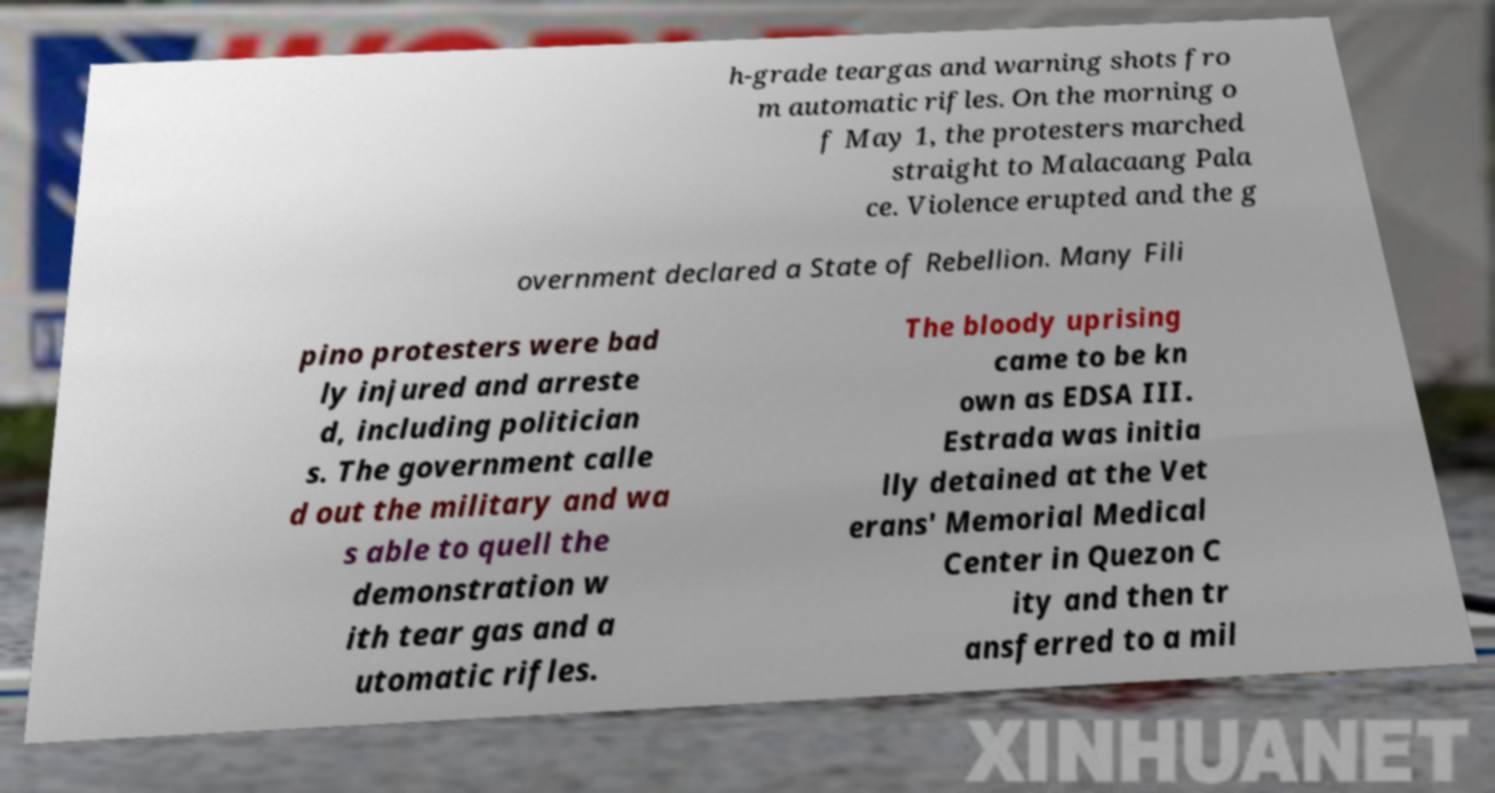Can you read and provide the text displayed in the image?This photo seems to have some interesting text. Can you extract and type it out for me? h-grade teargas and warning shots fro m automatic rifles. On the morning o f May 1, the protesters marched straight to Malacaang Pala ce. Violence erupted and the g overnment declared a State of Rebellion. Many Fili pino protesters were bad ly injured and arreste d, including politician s. The government calle d out the military and wa s able to quell the demonstration w ith tear gas and a utomatic rifles. The bloody uprising came to be kn own as EDSA III. Estrada was initia lly detained at the Vet erans' Memorial Medical Center in Quezon C ity and then tr ansferred to a mil 